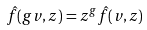Convert formula to latex. <formula><loc_0><loc_0><loc_500><loc_500>\hat { f } ( g v , z ) = z ^ { g } \hat { f } ( v , z )</formula> 